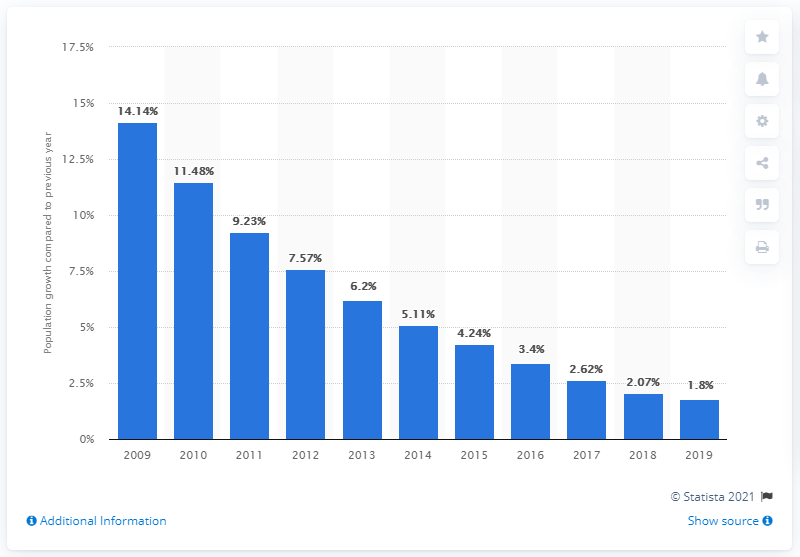Mention a couple of crucial points in this snapshot. According to the latest statistics, the population of Qatar increased by 1.8% in 2019. 